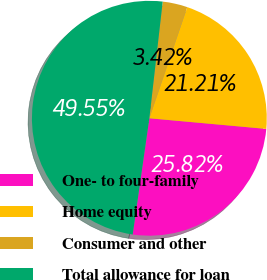Convert chart to OTSL. <chart><loc_0><loc_0><loc_500><loc_500><pie_chart><fcel>One- to four-family<fcel>Home equity<fcel>Consumer and other<fcel>Total allowance for loan<nl><fcel>25.82%<fcel>21.21%<fcel>3.42%<fcel>49.55%<nl></chart> 